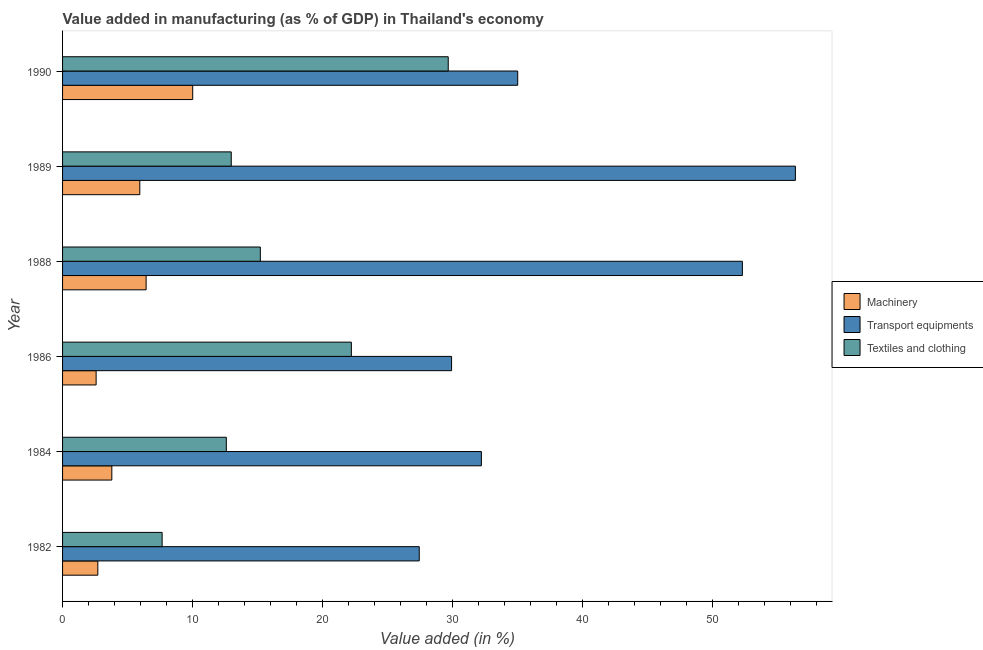How many different coloured bars are there?
Provide a succinct answer. 3. How many groups of bars are there?
Make the answer very short. 6. Are the number of bars on each tick of the Y-axis equal?
Your answer should be very brief. Yes. How many bars are there on the 6th tick from the bottom?
Offer a terse response. 3. What is the label of the 6th group of bars from the top?
Your response must be concise. 1982. In how many cases, is the number of bars for a given year not equal to the number of legend labels?
Offer a terse response. 0. What is the value added in manufacturing machinery in 1988?
Your answer should be very brief. 6.43. Across all years, what is the maximum value added in manufacturing machinery?
Provide a succinct answer. 10.01. Across all years, what is the minimum value added in manufacturing textile and clothing?
Provide a succinct answer. 7.66. In which year was the value added in manufacturing machinery maximum?
Your response must be concise. 1990. In which year was the value added in manufacturing textile and clothing minimum?
Offer a very short reply. 1982. What is the total value added in manufacturing machinery in the graph?
Your answer should be compact. 31.46. What is the difference between the value added in manufacturing textile and clothing in 1988 and that in 1989?
Provide a short and direct response. 2.24. What is the difference between the value added in manufacturing textile and clothing in 1990 and the value added in manufacturing transport equipments in 1982?
Keep it short and to the point. 2.23. What is the average value added in manufacturing machinery per year?
Ensure brevity in your answer.  5.24. In the year 1986, what is the difference between the value added in manufacturing transport equipments and value added in manufacturing machinery?
Give a very brief answer. 27.34. What is the ratio of the value added in manufacturing textile and clothing in 1986 to that in 1988?
Your response must be concise. 1.46. What is the difference between the highest and the second highest value added in manufacturing textile and clothing?
Ensure brevity in your answer.  7.45. What is the difference between the highest and the lowest value added in manufacturing machinery?
Your answer should be compact. 7.43. In how many years, is the value added in manufacturing machinery greater than the average value added in manufacturing machinery taken over all years?
Your response must be concise. 3. Is the sum of the value added in manufacturing machinery in 1986 and 1990 greater than the maximum value added in manufacturing textile and clothing across all years?
Ensure brevity in your answer.  No. What does the 2nd bar from the top in 1988 represents?
Provide a short and direct response. Transport equipments. What does the 3rd bar from the bottom in 1986 represents?
Offer a terse response. Textiles and clothing. Are all the bars in the graph horizontal?
Provide a succinct answer. Yes. How many years are there in the graph?
Provide a short and direct response. 6. What is the difference between two consecutive major ticks on the X-axis?
Ensure brevity in your answer.  10. Does the graph contain any zero values?
Provide a short and direct response. No. Where does the legend appear in the graph?
Provide a succinct answer. Center right. How many legend labels are there?
Offer a very short reply. 3. How are the legend labels stacked?
Your answer should be compact. Vertical. What is the title of the graph?
Your answer should be very brief. Value added in manufacturing (as % of GDP) in Thailand's economy. Does "Oil" appear as one of the legend labels in the graph?
Give a very brief answer. No. What is the label or title of the X-axis?
Your answer should be compact. Value added (in %). What is the Value added (in %) in Machinery in 1982?
Your answer should be compact. 2.71. What is the Value added (in %) of Transport equipments in 1982?
Provide a succinct answer. 27.43. What is the Value added (in %) in Textiles and clothing in 1982?
Your response must be concise. 7.66. What is the Value added (in %) of Machinery in 1984?
Your response must be concise. 3.79. What is the Value added (in %) of Transport equipments in 1984?
Provide a succinct answer. 32.21. What is the Value added (in %) in Textiles and clothing in 1984?
Your answer should be compact. 12.6. What is the Value added (in %) of Machinery in 1986?
Your response must be concise. 2.58. What is the Value added (in %) of Transport equipments in 1986?
Provide a succinct answer. 29.92. What is the Value added (in %) in Textiles and clothing in 1986?
Keep it short and to the point. 22.21. What is the Value added (in %) of Machinery in 1988?
Provide a succinct answer. 6.43. What is the Value added (in %) in Transport equipments in 1988?
Provide a short and direct response. 52.29. What is the Value added (in %) in Textiles and clothing in 1988?
Ensure brevity in your answer.  15.21. What is the Value added (in %) in Machinery in 1989?
Offer a terse response. 5.94. What is the Value added (in %) in Transport equipments in 1989?
Your response must be concise. 56.37. What is the Value added (in %) of Textiles and clothing in 1989?
Your response must be concise. 12.97. What is the Value added (in %) in Machinery in 1990?
Provide a short and direct response. 10.01. What is the Value added (in %) in Transport equipments in 1990?
Offer a terse response. 35.01. What is the Value added (in %) of Textiles and clothing in 1990?
Your response must be concise. 29.66. Across all years, what is the maximum Value added (in %) of Machinery?
Keep it short and to the point. 10.01. Across all years, what is the maximum Value added (in %) in Transport equipments?
Offer a terse response. 56.37. Across all years, what is the maximum Value added (in %) of Textiles and clothing?
Your response must be concise. 29.66. Across all years, what is the minimum Value added (in %) in Machinery?
Give a very brief answer. 2.58. Across all years, what is the minimum Value added (in %) of Transport equipments?
Your response must be concise. 27.43. Across all years, what is the minimum Value added (in %) of Textiles and clothing?
Give a very brief answer. 7.66. What is the total Value added (in %) of Machinery in the graph?
Provide a short and direct response. 31.46. What is the total Value added (in %) of Transport equipments in the graph?
Offer a very short reply. 233.23. What is the total Value added (in %) in Textiles and clothing in the graph?
Your response must be concise. 100.31. What is the difference between the Value added (in %) of Machinery in 1982 and that in 1984?
Make the answer very short. -1.08. What is the difference between the Value added (in %) in Transport equipments in 1982 and that in 1984?
Provide a succinct answer. -4.78. What is the difference between the Value added (in %) of Textiles and clothing in 1982 and that in 1984?
Give a very brief answer. -4.94. What is the difference between the Value added (in %) in Machinery in 1982 and that in 1986?
Provide a short and direct response. 0.13. What is the difference between the Value added (in %) in Transport equipments in 1982 and that in 1986?
Offer a very short reply. -2.49. What is the difference between the Value added (in %) in Textiles and clothing in 1982 and that in 1986?
Give a very brief answer. -14.56. What is the difference between the Value added (in %) in Machinery in 1982 and that in 1988?
Give a very brief answer. -3.71. What is the difference between the Value added (in %) in Transport equipments in 1982 and that in 1988?
Offer a very short reply. -24.85. What is the difference between the Value added (in %) of Textiles and clothing in 1982 and that in 1988?
Offer a terse response. -7.55. What is the difference between the Value added (in %) of Machinery in 1982 and that in 1989?
Your answer should be compact. -3.23. What is the difference between the Value added (in %) of Transport equipments in 1982 and that in 1989?
Keep it short and to the point. -28.93. What is the difference between the Value added (in %) in Textiles and clothing in 1982 and that in 1989?
Your answer should be very brief. -5.32. What is the difference between the Value added (in %) in Machinery in 1982 and that in 1990?
Your response must be concise. -7.3. What is the difference between the Value added (in %) in Transport equipments in 1982 and that in 1990?
Make the answer very short. -7.57. What is the difference between the Value added (in %) in Textiles and clothing in 1982 and that in 1990?
Your answer should be very brief. -22.01. What is the difference between the Value added (in %) in Machinery in 1984 and that in 1986?
Your response must be concise. 1.21. What is the difference between the Value added (in %) in Transport equipments in 1984 and that in 1986?
Ensure brevity in your answer.  2.29. What is the difference between the Value added (in %) of Textiles and clothing in 1984 and that in 1986?
Give a very brief answer. -9.62. What is the difference between the Value added (in %) in Machinery in 1984 and that in 1988?
Your response must be concise. -2.64. What is the difference between the Value added (in %) of Transport equipments in 1984 and that in 1988?
Your answer should be very brief. -20.07. What is the difference between the Value added (in %) of Textiles and clothing in 1984 and that in 1988?
Your answer should be very brief. -2.61. What is the difference between the Value added (in %) of Machinery in 1984 and that in 1989?
Your answer should be very brief. -2.15. What is the difference between the Value added (in %) of Transport equipments in 1984 and that in 1989?
Make the answer very short. -24.15. What is the difference between the Value added (in %) of Textiles and clothing in 1984 and that in 1989?
Your answer should be compact. -0.38. What is the difference between the Value added (in %) in Machinery in 1984 and that in 1990?
Make the answer very short. -6.22. What is the difference between the Value added (in %) in Transport equipments in 1984 and that in 1990?
Your response must be concise. -2.79. What is the difference between the Value added (in %) of Textiles and clothing in 1984 and that in 1990?
Ensure brevity in your answer.  -17.07. What is the difference between the Value added (in %) in Machinery in 1986 and that in 1988?
Offer a terse response. -3.85. What is the difference between the Value added (in %) of Transport equipments in 1986 and that in 1988?
Your response must be concise. -22.37. What is the difference between the Value added (in %) in Textiles and clothing in 1986 and that in 1988?
Provide a succinct answer. 7. What is the difference between the Value added (in %) in Machinery in 1986 and that in 1989?
Your answer should be very brief. -3.36. What is the difference between the Value added (in %) of Transport equipments in 1986 and that in 1989?
Provide a short and direct response. -26.44. What is the difference between the Value added (in %) of Textiles and clothing in 1986 and that in 1989?
Offer a terse response. 9.24. What is the difference between the Value added (in %) of Machinery in 1986 and that in 1990?
Ensure brevity in your answer.  -7.43. What is the difference between the Value added (in %) in Transport equipments in 1986 and that in 1990?
Your response must be concise. -5.09. What is the difference between the Value added (in %) of Textiles and clothing in 1986 and that in 1990?
Give a very brief answer. -7.45. What is the difference between the Value added (in %) of Machinery in 1988 and that in 1989?
Give a very brief answer. 0.49. What is the difference between the Value added (in %) in Transport equipments in 1988 and that in 1989?
Offer a very short reply. -4.08. What is the difference between the Value added (in %) of Textiles and clothing in 1988 and that in 1989?
Give a very brief answer. 2.24. What is the difference between the Value added (in %) of Machinery in 1988 and that in 1990?
Make the answer very short. -3.58. What is the difference between the Value added (in %) of Transport equipments in 1988 and that in 1990?
Provide a succinct answer. 17.28. What is the difference between the Value added (in %) of Textiles and clothing in 1988 and that in 1990?
Your answer should be compact. -14.45. What is the difference between the Value added (in %) in Machinery in 1989 and that in 1990?
Offer a terse response. -4.07. What is the difference between the Value added (in %) in Transport equipments in 1989 and that in 1990?
Offer a very short reply. 21.36. What is the difference between the Value added (in %) in Textiles and clothing in 1989 and that in 1990?
Give a very brief answer. -16.69. What is the difference between the Value added (in %) of Machinery in 1982 and the Value added (in %) of Transport equipments in 1984?
Offer a terse response. -29.5. What is the difference between the Value added (in %) of Machinery in 1982 and the Value added (in %) of Textiles and clothing in 1984?
Your answer should be very brief. -9.88. What is the difference between the Value added (in %) in Transport equipments in 1982 and the Value added (in %) in Textiles and clothing in 1984?
Give a very brief answer. 14.84. What is the difference between the Value added (in %) in Machinery in 1982 and the Value added (in %) in Transport equipments in 1986?
Make the answer very short. -27.21. What is the difference between the Value added (in %) in Machinery in 1982 and the Value added (in %) in Textiles and clothing in 1986?
Provide a succinct answer. -19.5. What is the difference between the Value added (in %) in Transport equipments in 1982 and the Value added (in %) in Textiles and clothing in 1986?
Ensure brevity in your answer.  5.22. What is the difference between the Value added (in %) in Machinery in 1982 and the Value added (in %) in Transport equipments in 1988?
Provide a succinct answer. -49.57. What is the difference between the Value added (in %) in Machinery in 1982 and the Value added (in %) in Textiles and clothing in 1988?
Make the answer very short. -12.5. What is the difference between the Value added (in %) in Transport equipments in 1982 and the Value added (in %) in Textiles and clothing in 1988?
Your answer should be very brief. 12.22. What is the difference between the Value added (in %) of Machinery in 1982 and the Value added (in %) of Transport equipments in 1989?
Provide a succinct answer. -53.65. What is the difference between the Value added (in %) in Machinery in 1982 and the Value added (in %) in Textiles and clothing in 1989?
Offer a very short reply. -10.26. What is the difference between the Value added (in %) of Transport equipments in 1982 and the Value added (in %) of Textiles and clothing in 1989?
Your answer should be very brief. 14.46. What is the difference between the Value added (in %) of Machinery in 1982 and the Value added (in %) of Transport equipments in 1990?
Ensure brevity in your answer.  -32.29. What is the difference between the Value added (in %) in Machinery in 1982 and the Value added (in %) in Textiles and clothing in 1990?
Provide a succinct answer. -26.95. What is the difference between the Value added (in %) in Transport equipments in 1982 and the Value added (in %) in Textiles and clothing in 1990?
Your answer should be very brief. -2.23. What is the difference between the Value added (in %) of Machinery in 1984 and the Value added (in %) of Transport equipments in 1986?
Make the answer very short. -26.13. What is the difference between the Value added (in %) of Machinery in 1984 and the Value added (in %) of Textiles and clothing in 1986?
Ensure brevity in your answer.  -18.42. What is the difference between the Value added (in %) in Transport equipments in 1984 and the Value added (in %) in Textiles and clothing in 1986?
Ensure brevity in your answer.  10. What is the difference between the Value added (in %) of Machinery in 1984 and the Value added (in %) of Transport equipments in 1988?
Your response must be concise. -48.5. What is the difference between the Value added (in %) of Machinery in 1984 and the Value added (in %) of Textiles and clothing in 1988?
Provide a short and direct response. -11.42. What is the difference between the Value added (in %) in Transport equipments in 1984 and the Value added (in %) in Textiles and clothing in 1988?
Your response must be concise. 17. What is the difference between the Value added (in %) in Machinery in 1984 and the Value added (in %) in Transport equipments in 1989?
Offer a terse response. -52.58. What is the difference between the Value added (in %) in Machinery in 1984 and the Value added (in %) in Textiles and clothing in 1989?
Your answer should be compact. -9.18. What is the difference between the Value added (in %) of Transport equipments in 1984 and the Value added (in %) of Textiles and clothing in 1989?
Provide a short and direct response. 19.24. What is the difference between the Value added (in %) in Machinery in 1984 and the Value added (in %) in Transport equipments in 1990?
Offer a very short reply. -31.22. What is the difference between the Value added (in %) in Machinery in 1984 and the Value added (in %) in Textiles and clothing in 1990?
Offer a terse response. -25.87. What is the difference between the Value added (in %) of Transport equipments in 1984 and the Value added (in %) of Textiles and clothing in 1990?
Offer a very short reply. 2.55. What is the difference between the Value added (in %) in Machinery in 1986 and the Value added (in %) in Transport equipments in 1988?
Make the answer very short. -49.71. What is the difference between the Value added (in %) of Machinery in 1986 and the Value added (in %) of Textiles and clothing in 1988?
Provide a succinct answer. -12.63. What is the difference between the Value added (in %) in Transport equipments in 1986 and the Value added (in %) in Textiles and clothing in 1988?
Ensure brevity in your answer.  14.71. What is the difference between the Value added (in %) of Machinery in 1986 and the Value added (in %) of Transport equipments in 1989?
Your response must be concise. -53.78. What is the difference between the Value added (in %) in Machinery in 1986 and the Value added (in %) in Textiles and clothing in 1989?
Your answer should be very brief. -10.39. What is the difference between the Value added (in %) of Transport equipments in 1986 and the Value added (in %) of Textiles and clothing in 1989?
Make the answer very short. 16.95. What is the difference between the Value added (in %) in Machinery in 1986 and the Value added (in %) in Transport equipments in 1990?
Your response must be concise. -32.43. What is the difference between the Value added (in %) in Machinery in 1986 and the Value added (in %) in Textiles and clothing in 1990?
Provide a short and direct response. -27.08. What is the difference between the Value added (in %) of Transport equipments in 1986 and the Value added (in %) of Textiles and clothing in 1990?
Your answer should be compact. 0.26. What is the difference between the Value added (in %) in Machinery in 1988 and the Value added (in %) in Transport equipments in 1989?
Your response must be concise. -49.94. What is the difference between the Value added (in %) in Machinery in 1988 and the Value added (in %) in Textiles and clothing in 1989?
Offer a terse response. -6.55. What is the difference between the Value added (in %) of Transport equipments in 1988 and the Value added (in %) of Textiles and clothing in 1989?
Provide a short and direct response. 39.31. What is the difference between the Value added (in %) of Machinery in 1988 and the Value added (in %) of Transport equipments in 1990?
Make the answer very short. -28.58. What is the difference between the Value added (in %) of Machinery in 1988 and the Value added (in %) of Textiles and clothing in 1990?
Your answer should be compact. -23.24. What is the difference between the Value added (in %) in Transport equipments in 1988 and the Value added (in %) in Textiles and clothing in 1990?
Ensure brevity in your answer.  22.62. What is the difference between the Value added (in %) in Machinery in 1989 and the Value added (in %) in Transport equipments in 1990?
Offer a very short reply. -29.07. What is the difference between the Value added (in %) in Machinery in 1989 and the Value added (in %) in Textiles and clothing in 1990?
Offer a very short reply. -23.72. What is the difference between the Value added (in %) in Transport equipments in 1989 and the Value added (in %) in Textiles and clothing in 1990?
Make the answer very short. 26.7. What is the average Value added (in %) of Machinery per year?
Make the answer very short. 5.24. What is the average Value added (in %) of Transport equipments per year?
Make the answer very short. 38.87. What is the average Value added (in %) in Textiles and clothing per year?
Give a very brief answer. 16.72. In the year 1982, what is the difference between the Value added (in %) of Machinery and Value added (in %) of Transport equipments?
Your answer should be compact. -24.72. In the year 1982, what is the difference between the Value added (in %) in Machinery and Value added (in %) in Textiles and clothing?
Make the answer very short. -4.95. In the year 1982, what is the difference between the Value added (in %) in Transport equipments and Value added (in %) in Textiles and clothing?
Your answer should be compact. 19.78. In the year 1984, what is the difference between the Value added (in %) of Machinery and Value added (in %) of Transport equipments?
Provide a short and direct response. -28.42. In the year 1984, what is the difference between the Value added (in %) of Machinery and Value added (in %) of Textiles and clothing?
Keep it short and to the point. -8.81. In the year 1984, what is the difference between the Value added (in %) in Transport equipments and Value added (in %) in Textiles and clothing?
Your answer should be compact. 19.62. In the year 1986, what is the difference between the Value added (in %) of Machinery and Value added (in %) of Transport equipments?
Offer a terse response. -27.34. In the year 1986, what is the difference between the Value added (in %) of Machinery and Value added (in %) of Textiles and clothing?
Keep it short and to the point. -19.63. In the year 1986, what is the difference between the Value added (in %) in Transport equipments and Value added (in %) in Textiles and clothing?
Ensure brevity in your answer.  7.71. In the year 1988, what is the difference between the Value added (in %) in Machinery and Value added (in %) in Transport equipments?
Offer a terse response. -45.86. In the year 1988, what is the difference between the Value added (in %) of Machinery and Value added (in %) of Textiles and clothing?
Provide a succinct answer. -8.78. In the year 1988, what is the difference between the Value added (in %) of Transport equipments and Value added (in %) of Textiles and clothing?
Make the answer very short. 37.08. In the year 1989, what is the difference between the Value added (in %) in Machinery and Value added (in %) in Transport equipments?
Ensure brevity in your answer.  -50.42. In the year 1989, what is the difference between the Value added (in %) of Machinery and Value added (in %) of Textiles and clothing?
Your response must be concise. -7.03. In the year 1989, what is the difference between the Value added (in %) of Transport equipments and Value added (in %) of Textiles and clothing?
Your response must be concise. 43.39. In the year 1990, what is the difference between the Value added (in %) in Machinery and Value added (in %) in Transport equipments?
Provide a short and direct response. -25. In the year 1990, what is the difference between the Value added (in %) of Machinery and Value added (in %) of Textiles and clothing?
Provide a succinct answer. -19.66. In the year 1990, what is the difference between the Value added (in %) of Transport equipments and Value added (in %) of Textiles and clothing?
Your answer should be compact. 5.34. What is the ratio of the Value added (in %) of Machinery in 1982 to that in 1984?
Give a very brief answer. 0.72. What is the ratio of the Value added (in %) in Transport equipments in 1982 to that in 1984?
Provide a succinct answer. 0.85. What is the ratio of the Value added (in %) in Textiles and clothing in 1982 to that in 1984?
Provide a succinct answer. 0.61. What is the ratio of the Value added (in %) of Machinery in 1982 to that in 1986?
Your answer should be very brief. 1.05. What is the ratio of the Value added (in %) of Transport equipments in 1982 to that in 1986?
Make the answer very short. 0.92. What is the ratio of the Value added (in %) in Textiles and clothing in 1982 to that in 1986?
Give a very brief answer. 0.34. What is the ratio of the Value added (in %) in Machinery in 1982 to that in 1988?
Make the answer very short. 0.42. What is the ratio of the Value added (in %) in Transport equipments in 1982 to that in 1988?
Keep it short and to the point. 0.52. What is the ratio of the Value added (in %) in Textiles and clothing in 1982 to that in 1988?
Your answer should be compact. 0.5. What is the ratio of the Value added (in %) of Machinery in 1982 to that in 1989?
Ensure brevity in your answer.  0.46. What is the ratio of the Value added (in %) of Transport equipments in 1982 to that in 1989?
Provide a short and direct response. 0.49. What is the ratio of the Value added (in %) of Textiles and clothing in 1982 to that in 1989?
Your response must be concise. 0.59. What is the ratio of the Value added (in %) of Machinery in 1982 to that in 1990?
Keep it short and to the point. 0.27. What is the ratio of the Value added (in %) of Transport equipments in 1982 to that in 1990?
Ensure brevity in your answer.  0.78. What is the ratio of the Value added (in %) in Textiles and clothing in 1982 to that in 1990?
Keep it short and to the point. 0.26. What is the ratio of the Value added (in %) in Machinery in 1984 to that in 1986?
Keep it short and to the point. 1.47. What is the ratio of the Value added (in %) in Transport equipments in 1984 to that in 1986?
Keep it short and to the point. 1.08. What is the ratio of the Value added (in %) of Textiles and clothing in 1984 to that in 1986?
Keep it short and to the point. 0.57. What is the ratio of the Value added (in %) of Machinery in 1984 to that in 1988?
Your answer should be very brief. 0.59. What is the ratio of the Value added (in %) of Transport equipments in 1984 to that in 1988?
Provide a short and direct response. 0.62. What is the ratio of the Value added (in %) in Textiles and clothing in 1984 to that in 1988?
Ensure brevity in your answer.  0.83. What is the ratio of the Value added (in %) in Machinery in 1984 to that in 1989?
Your answer should be very brief. 0.64. What is the ratio of the Value added (in %) of Transport equipments in 1984 to that in 1989?
Offer a very short reply. 0.57. What is the ratio of the Value added (in %) in Textiles and clothing in 1984 to that in 1989?
Your response must be concise. 0.97. What is the ratio of the Value added (in %) in Machinery in 1984 to that in 1990?
Make the answer very short. 0.38. What is the ratio of the Value added (in %) in Transport equipments in 1984 to that in 1990?
Your answer should be very brief. 0.92. What is the ratio of the Value added (in %) in Textiles and clothing in 1984 to that in 1990?
Provide a short and direct response. 0.42. What is the ratio of the Value added (in %) of Machinery in 1986 to that in 1988?
Offer a terse response. 0.4. What is the ratio of the Value added (in %) of Transport equipments in 1986 to that in 1988?
Give a very brief answer. 0.57. What is the ratio of the Value added (in %) of Textiles and clothing in 1986 to that in 1988?
Ensure brevity in your answer.  1.46. What is the ratio of the Value added (in %) in Machinery in 1986 to that in 1989?
Offer a terse response. 0.43. What is the ratio of the Value added (in %) of Transport equipments in 1986 to that in 1989?
Offer a terse response. 0.53. What is the ratio of the Value added (in %) of Textiles and clothing in 1986 to that in 1989?
Your answer should be very brief. 1.71. What is the ratio of the Value added (in %) of Machinery in 1986 to that in 1990?
Your response must be concise. 0.26. What is the ratio of the Value added (in %) in Transport equipments in 1986 to that in 1990?
Provide a succinct answer. 0.85. What is the ratio of the Value added (in %) of Textiles and clothing in 1986 to that in 1990?
Offer a very short reply. 0.75. What is the ratio of the Value added (in %) in Machinery in 1988 to that in 1989?
Give a very brief answer. 1.08. What is the ratio of the Value added (in %) in Transport equipments in 1988 to that in 1989?
Your response must be concise. 0.93. What is the ratio of the Value added (in %) in Textiles and clothing in 1988 to that in 1989?
Provide a succinct answer. 1.17. What is the ratio of the Value added (in %) of Machinery in 1988 to that in 1990?
Give a very brief answer. 0.64. What is the ratio of the Value added (in %) of Transport equipments in 1988 to that in 1990?
Provide a short and direct response. 1.49. What is the ratio of the Value added (in %) of Textiles and clothing in 1988 to that in 1990?
Ensure brevity in your answer.  0.51. What is the ratio of the Value added (in %) of Machinery in 1989 to that in 1990?
Provide a succinct answer. 0.59. What is the ratio of the Value added (in %) of Transport equipments in 1989 to that in 1990?
Provide a succinct answer. 1.61. What is the ratio of the Value added (in %) of Textiles and clothing in 1989 to that in 1990?
Offer a very short reply. 0.44. What is the difference between the highest and the second highest Value added (in %) in Machinery?
Provide a short and direct response. 3.58. What is the difference between the highest and the second highest Value added (in %) in Transport equipments?
Your answer should be very brief. 4.08. What is the difference between the highest and the second highest Value added (in %) in Textiles and clothing?
Keep it short and to the point. 7.45. What is the difference between the highest and the lowest Value added (in %) in Machinery?
Your answer should be very brief. 7.43. What is the difference between the highest and the lowest Value added (in %) of Transport equipments?
Your answer should be compact. 28.93. What is the difference between the highest and the lowest Value added (in %) in Textiles and clothing?
Your response must be concise. 22.01. 